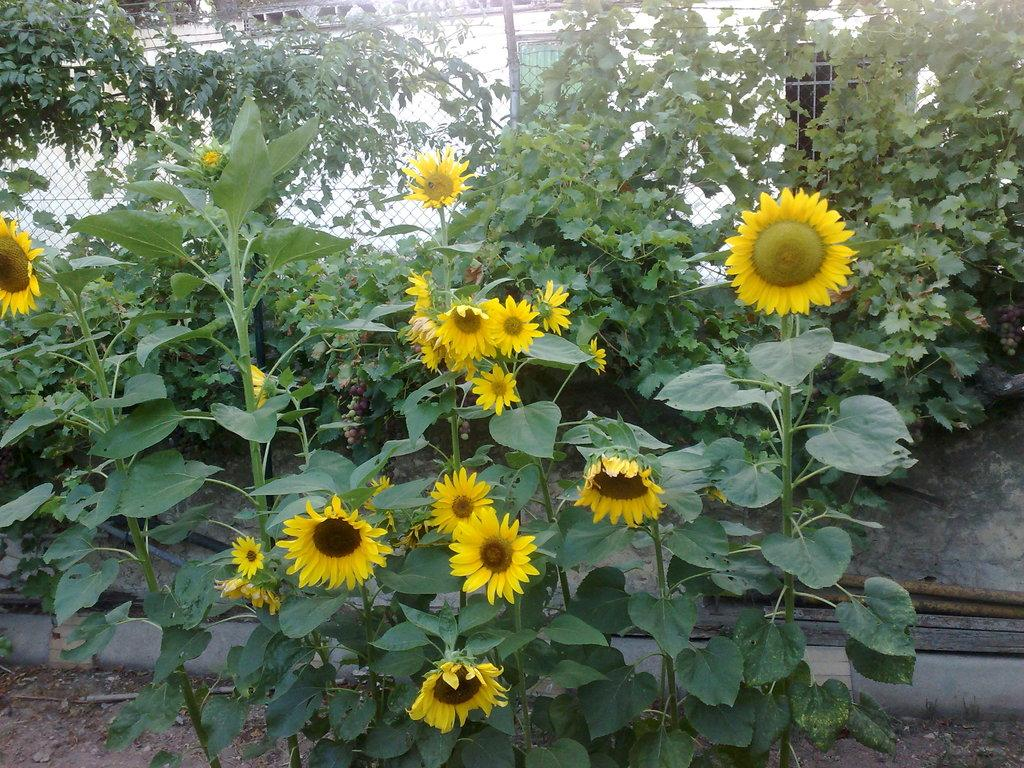What type of plants are in the image? There are sunflowers in the image. What else can be seen in the image besides the sunflowers? There are plants and fencing visible in the image. What is located behind the sunflower plants? There is fencing behind the sunflower plants. What can be seen behind the fencing? There are plants visible behind the fencing. What architectural feature is visible in the image? There is a wall with windows visible in the image. What type of pocket can be seen on the sunflower in the image? There are no pockets present on the sunflowers in the image, as sunflowers are plants and do not have pockets. 